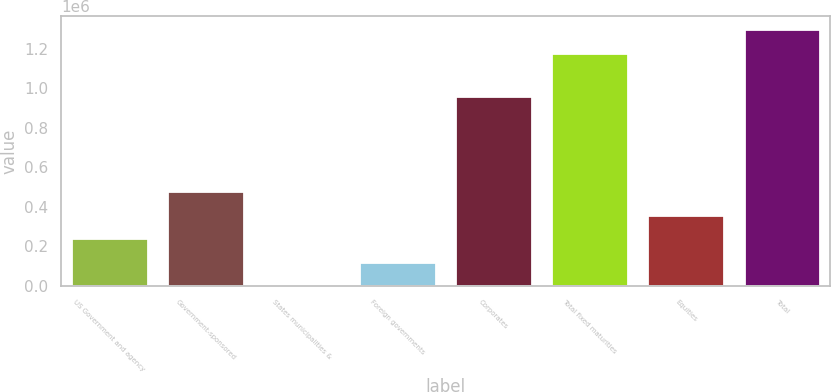Convert chart to OTSL. <chart><loc_0><loc_0><loc_500><loc_500><bar_chart><fcel>US Government and agency<fcel>Government-sponsored<fcel>States municipalities &<fcel>Foreign governments<fcel>Corporates<fcel>Total fixed maturities<fcel>Equities<fcel>Total<nl><fcel>239166<fcel>478328<fcel>3.37<fcel>119585<fcel>962850<fcel>1.17951e+06<fcel>358747<fcel>1.29909e+06<nl></chart> 